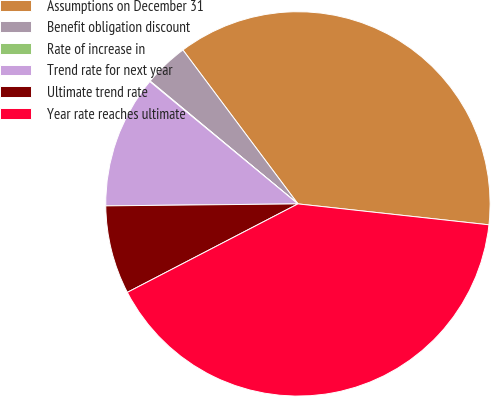<chart> <loc_0><loc_0><loc_500><loc_500><pie_chart><fcel>Assumptions on December 31<fcel>Benefit obligation discount<fcel>Rate of increase in<fcel>Trend rate for next year<fcel>Ultimate trend rate<fcel>Year rate reaches ultimate<nl><fcel>36.95%<fcel>3.75%<fcel>0.05%<fcel>11.15%<fcel>7.45%<fcel>40.65%<nl></chart> 